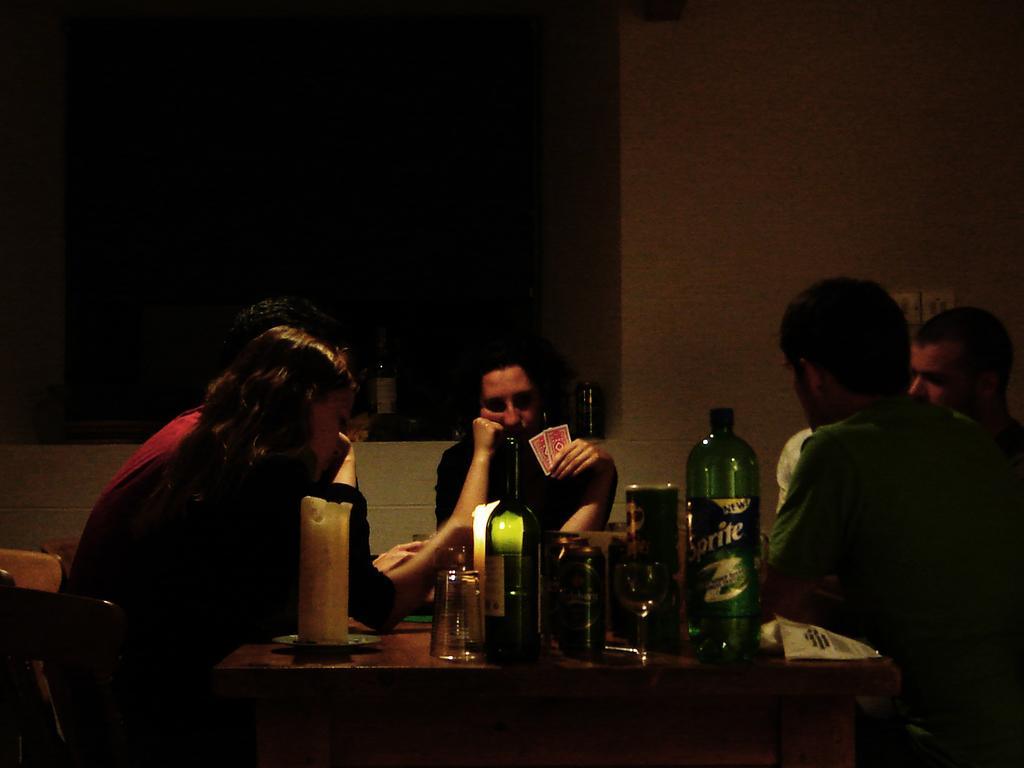Can you describe this image briefly? There are group of people in this image sitting on the chair. The person in the center is holding card in his hand. On the table there are bottle glass. In the background there is a wall. 